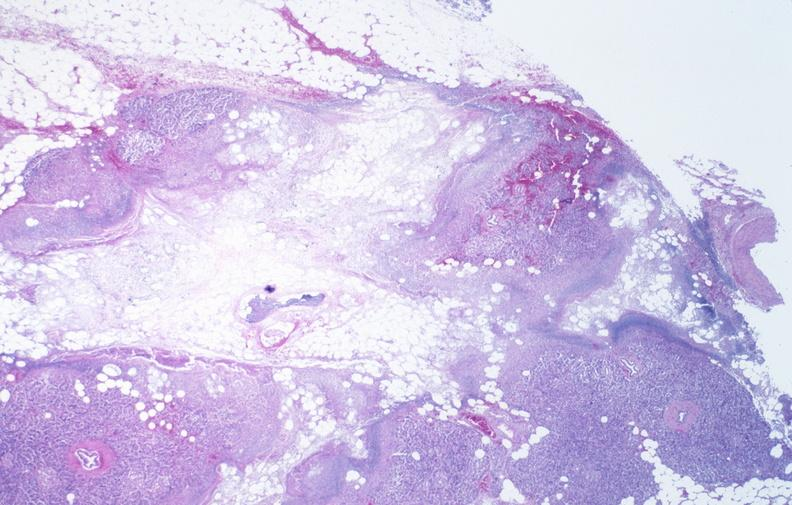does this image show pancreatic fat necrosis?
Answer the question using a single word or phrase. Yes 